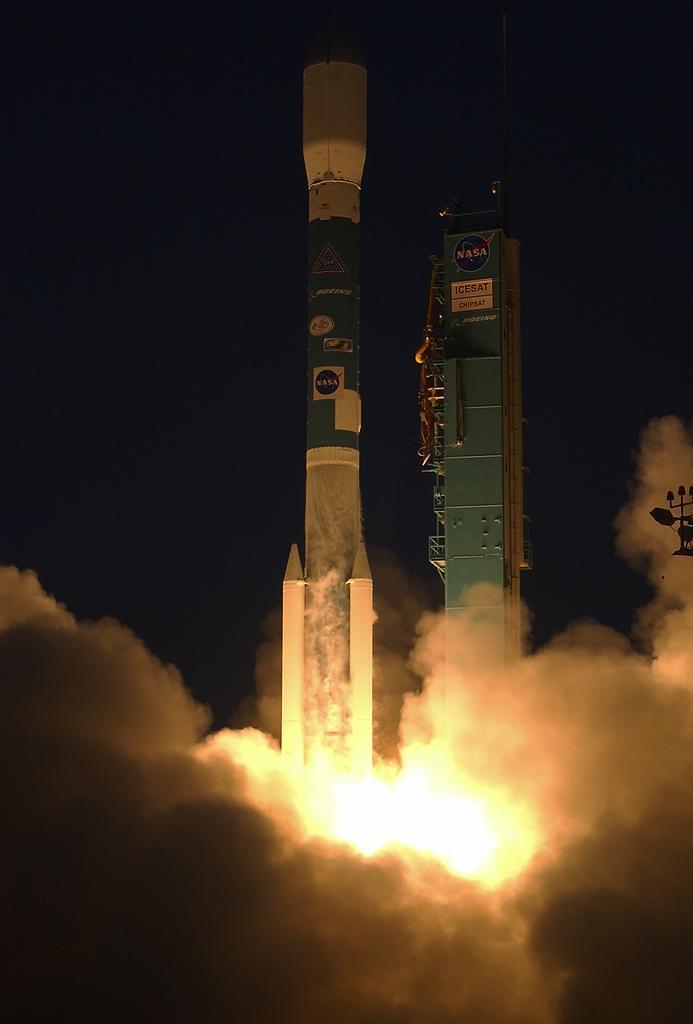Describe this image in one or two sentences. In this image there is a rocket, there is the fire, there is smoke truncated towards the bottom of the image, there is an object, there is text on the object, there is an object truncated towards the right of the image, the background of the image is dark. 